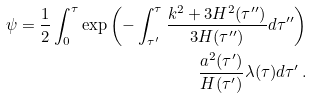<formula> <loc_0><loc_0><loc_500><loc_500>\psi = \frac { 1 } { 2 } \int _ { 0 } ^ { \tau } \exp \left ( - \int _ { \tau ^ { \prime } } ^ { \tau } \frac { k ^ { 2 } + 3 H ^ { 2 } ( \tau ^ { \prime \prime } ) } { 3 H ( \tau ^ { \prime \prime } ) } d \tau ^ { \prime \prime } \right ) \\ \frac { a ^ { 2 } ( \tau ^ { \prime } ) } { H ( \tau ^ { \prime } ) } \lambda ( \tau ) d \tau ^ { \prime } \, .</formula> 